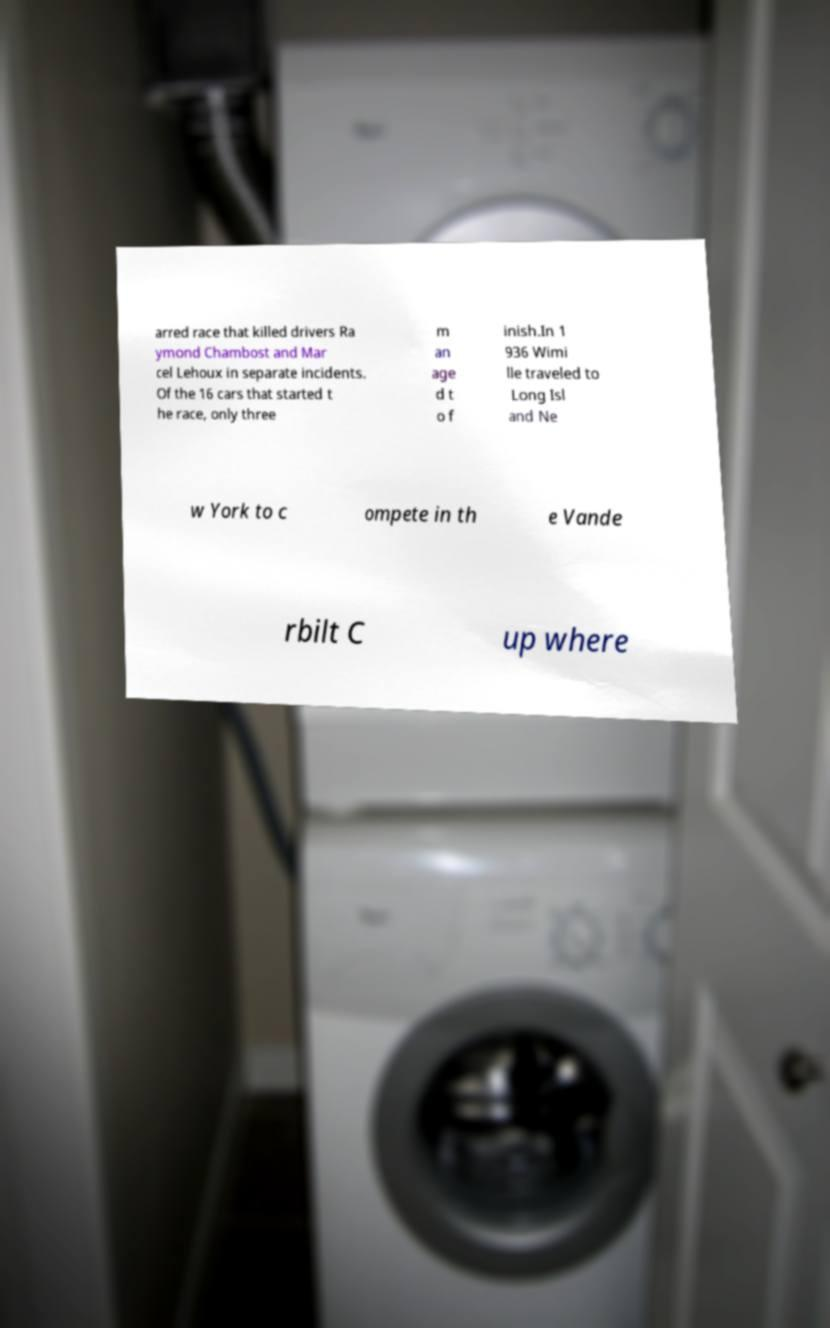Can you read and provide the text displayed in the image?This photo seems to have some interesting text. Can you extract and type it out for me? arred race that killed drivers Ra ymond Chambost and Mar cel Lehoux in separate incidents. Of the 16 cars that started t he race, only three m an age d t o f inish.In 1 936 Wimi lle traveled to Long Isl and Ne w York to c ompete in th e Vande rbilt C up where 